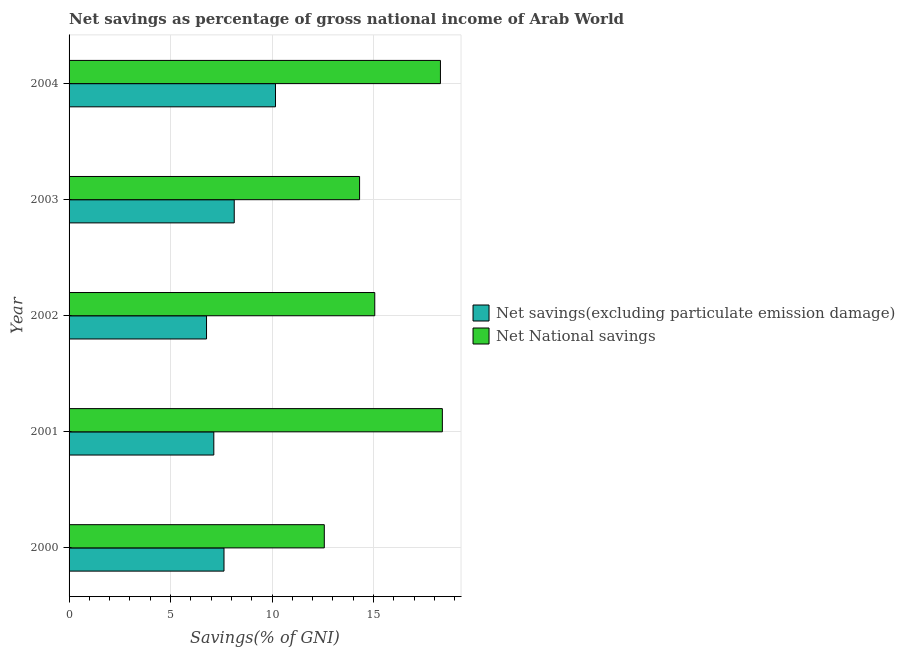How many groups of bars are there?
Give a very brief answer. 5. Are the number of bars per tick equal to the number of legend labels?
Make the answer very short. Yes. In how many cases, is the number of bars for a given year not equal to the number of legend labels?
Offer a very short reply. 0. What is the net savings(excluding particulate emission damage) in 2002?
Offer a terse response. 6.77. Across all years, what is the maximum net savings(excluding particulate emission damage)?
Make the answer very short. 10.17. Across all years, what is the minimum net savings(excluding particulate emission damage)?
Your answer should be compact. 6.77. In which year was the net national savings maximum?
Provide a succinct answer. 2001. In which year was the net savings(excluding particulate emission damage) minimum?
Your answer should be very brief. 2002. What is the total net savings(excluding particulate emission damage) in the graph?
Provide a short and direct response. 39.85. What is the difference between the net national savings in 2000 and that in 2003?
Your response must be concise. -1.74. What is the difference between the net national savings in 2000 and the net savings(excluding particulate emission damage) in 2004?
Keep it short and to the point. 2.41. What is the average net national savings per year?
Provide a succinct answer. 15.73. In the year 2002, what is the difference between the net national savings and net savings(excluding particulate emission damage)?
Your response must be concise. 8.29. In how many years, is the net national savings greater than 8 %?
Ensure brevity in your answer.  5. What is the ratio of the net national savings in 2000 to that in 2002?
Keep it short and to the point. 0.83. Is the net national savings in 2001 less than that in 2002?
Give a very brief answer. No. Is the difference between the net national savings in 2000 and 2003 greater than the difference between the net savings(excluding particulate emission damage) in 2000 and 2003?
Your answer should be very brief. No. What is the difference between the highest and the second highest net savings(excluding particulate emission damage)?
Keep it short and to the point. 2.03. What is the difference between the highest and the lowest net national savings?
Provide a short and direct response. 5.82. In how many years, is the net savings(excluding particulate emission damage) greater than the average net savings(excluding particulate emission damage) taken over all years?
Offer a very short reply. 2. What does the 1st bar from the top in 2002 represents?
Your answer should be compact. Net National savings. What does the 2nd bar from the bottom in 2003 represents?
Keep it short and to the point. Net National savings. Are all the bars in the graph horizontal?
Ensure brevity in your answer.  Yes. Where does the legend appear in the graph?
Give a very brief answer. Center right. How are the legend labels stacked?
Keep it short and to the point. Vertical. What is the title of the graph?
Offer a very short reply. Net savings as percentage of gross national income of Arab World. What is the label or title of the X-axis?
Provide a short and direct response. Savings(% of GNI). What is the Savings(% of GNI) of Net savings(excluding particulate emission damage) in 2000?
Provide a succinct answer. 7.63. What is the Savings(% of GNI) of Net National savings in 2000?
Keep it short and to the point. 12.58. What is the Savings(% of GNI) in Net savings(excluding particulate emission damage) in 2001?
Provide a short and direct response. 7.13. What is the Savings(% of GNI) in Net National savings in 2001?
Offer a very short reply. 18.39. What is the Savings(% of GNI) in Net savings(excluding particulate emission damage) in 2002?
Offer a terse response. 6.77. What is the Savings(% of GNI) in Net National savings in 2002?
Ensure brevity in your answer.  15.06. What is the Savings(% of GNI) of Net savings(excluding particulate emission damage) in 2003?
Give a very brief answer. 8.14. What is the Savings(% of GNI) in Net National savings in 2003?
Provide a short and direct response. 14.32. What is the Savings(% of GNI) in Net savings(excluding particulate emission damage) in 2004?
Offer a very short reply. 10.17. What is the Savings(% of GNI) in Net National savings in 2004?
Your answer should be compact. 18.3. Across all years, what is the maximum Savings(% of GNI) of Net savings(excluding particulate emission damage)?
Make the answer very short. 10.17. Across all years, what is the maximum Savings(% of GNI) of Net National savings?
Provide a short and direct response. 18.39. Across all years, what is the minimum Savings(% of GNI) of Net savings(excluding particulate emission damage)?
Offer a terse response. 6.77. Across all years, what is the minimum Savings(% of GNI) of Net National savings?
Ensure brevity in your answer.  12.58. What is the total Savings(% of GNI) of Net savings(excluding particulate emission damage) in the graph?
Give a very brief answer. 39.85. What is the total Savings(% of GNI) of Net National savings in the graph?
Give a very brief answer. 78.65. What is the difference between the Savings(% of GNI) of Net savings(excluding particulate emission damage) in 2000 and that in 2001?
Offer a very short reply. 0.5. What is the difference between the Savings(% of GNI) in Net National savings in 2000 and that in 2001?
Your response must be concise. -5.82. What is the difference between the Savings(% of GNI) of Net savings(excluding particulate emission damage) in 2000 and that in 2002?
Ensure brevity in your answer.  0.86. What is the difference between the Savings(% of GNI) of Net National savings in 2000 and that in 2002?
Your answer should be very brief. -2.49. What is the difference between the Savings(% of GNI) in Net savings(excluding particulate emission damage) in 2000 and that in 2003?
Offer a terse response. -0.5. What is the difference between the Savings(% of GNI) in Net National savings in 2000 and that in 2003?
Give a very brief answer. -1.74. What is the difference between the Savings(% of GNI) of Net savings(excluding particulate emission damage) in 2000 and that in 2004?
Your answer should be very brief. -2.54. What is the difference between the Savings(% of GNI) of Net National savings in 2000 and that in 2004?
Offer a terse response. -5.72. What is the difference between the Savings(% of GNI) of Net savings(excluding particulate emission damage) in 2001 and that in 2002?
Your answer should be compact. 0.36. What is the difference between the Savings(% of GNI) of Net National savings in 2001 and that in 2002?
Keep it short and to the point. 3.33. What is the difference between the Savings(% of GNI) of Net savings(excluding particulate emission damage) in 2001 and that in 2003?
Ensure brevity in your answer.  -1.01. What is the difference between the Savings(% of GNI) of Net National savings in 2001 and that in 2003?
Keep it short and to the point. 4.08. What is the difference between the Savings(% of GNI) in Net savings(excluding particulate emission damage) in 2001 and that in 2004?
Provide a succinct answer. -3.04. What is the difference between the Savings(% of GNI) of Net National savings in 2001 and that in 2004?
Provide a succinct answer. 0.09. What is the difference between the Savings(% of GNI) in Net savings(excluding particulate emission damage) in 2002 and that in 2003?
Your response must be concise. -1.37. What is the difference between the Savings(% of GNI) in Net National savings in 2002 and that in 2003?
Provide a succinct answer. 0.75. What is the difference between the Savings(% of GNI) in Net savings(excluding particulate emission damage) in 2002 and that in 2004?
Keep it short and to the point. -3.4. What is the difference between the Savings(% of GNI) of Net National savings in 2002 and that in 2004?
Your answer should be compact. -3.24. What is the difference between the Savings(% of GNI) of Net savings(excluding particulate emission damage) in 2003 and that in 2004?
Offer a terse response. -2.03. What is the difference between the Savings(% of GNI) in Net National savings in 2003 and that in 2004?
Your answer should be very brief. -3.98. What is the difference between the Savings(% of GNI) in Net savings(excluding particulate emission damage) in 2000 and the Savings(% of GNI) in Net National savings in 2001?
Your answer should be compact. -10.76. What is the difference between the Savings(% of GNI) of Net savings(excluding particulate emission damage) in 2000 and the Savings(% of GNI) of Net National savings in 2002?
Keep it short and to the point. -7.43. What is the difference between the Savings(% of GNI) of Net savings(excluding particulate emission damage) in 2000 and the Savings(% of GNI) of Net National savings in 2003?
Your response must be concise. -6.68. What is the difference between the Savings(% of GNI) in Net savings(excluding particulate emission damage) in 2000 and the Savings(% of GNI) in Net National savings in 2004?
Your response must be concise. -10.67. What is the difference between the Savings(% of GNI) in Net savings(excluding particulate emission damage) in 2001 and the Savings(% of GNI) in Net National savings in 2002?
Offer a terse response. -7.93. What is the difference between the Savings(% of GNI) of Net savings(excluding particulate emission damage) in 2001 and the Savings(% of GNI) of Net National savings in 2003?
Your answer should be very brief. -7.18. What is the difference between the Savings(% of GNI) of Net savings(excluding particulate emission damage) in 2001 and the Savings(% of GNI) of Net National savings in 2004?
Ensure brevity in your answer.  -11.17. What is the difference between the Savings(% of GNI) in Net savings(excluding particulate emission damage) in 2002 and the Savings(% of GNI) in Net National savings in 2003?
Make the answer very short. -7.54. What is the difference between the Savings(% of GNI) in Net savings(excluding particulate emission damage) in 2002 and the Savings(% of GNI) in Net National savings in 2004?
Your answer should be compact. -11.53. What is the difference between the Savings(% of GNI) in Net savings(excluding particulate emission damage) in 2003 and the Savings(% of GNI) in Net National savings in 2004?
Provide a succinct answer. -10.16. What is the average Savings(% of GNI) in Net savings(excluding particulate emission damage) per year?
Your answer should be compact. 7.97. What is the average Savings(% of GNI) in Net National savings per year?
Your answer should be very brief. 15.73. In the year 2000, what is the difference between the Savings(% of GNI) of Net savings(excluding particulate emission damage) and Savings(% of GNI) of Net National savings?
Make the answer very short. -4.94. In the year 2001, what is the difference between the Savings(% of GNI) in Net savings(excluding particulate emission damage) and Savings(% of GNI) in Net National savings?
Your answer should be very brief. -11.26. In the year 2002, what is the difference between the Savings(% of GNI) of Net savings(excluding particulate emission damage) and Savings(% of GNI) of Net National savings?
Your answer should be compact. -8.29. In the year 2003, what is the difference between the Savings(% of GNI) of Net savings(excluding particulate emission damage) and Savings(% of GNI) of Net National savings?
Your response must be concise. -6.18. In the year 2004, what is the difference between the Savings(% of GNI) of Net savings(excluding particulate emission damage) and Savings(% of GNI) of Net National savings?
Keep it short and to the point. -8.13. What is the ratio of the Savings(% of GNI) of Net savings(excluding particulate emission damage) in 2000 to that in 2001?
Offer a terse response. 1.07. What is the ratio of the Savings(% of GNI) in Net National savings in 2000 to that in 2001?
Your answer should be compact. 0.68. What is the ratio of the Savings(% of GNI) of Net savings(excluding particulate emission damage) in 2000 to that in 2002?
Give a very brief answer. 1.13. What is the ratio of the Savings(% of GNI) of Net National savings in 2000 to that in 2002?
Make the answer very short. 0.83. What is the ratio of the Savings(% of GNI) in Net savings(excluding particulate emission damage) in 2000 to that in 2003?
Your answer should be very brief. 0.94. What is the ratio of the Savings(% of GNI) of Net National savings in 2000 to that in 2003?
Your answer should be very brief. 0.88. What is the ratio of the Savings(% of GNI) in Net savings(excluding particulate emission damage) in 2000 to that in 2004?
Provide a short and direct response. 0.75. What is the ratio of the Savings(% of GNI) of Net National savings in 2000 to that in 2004?
Your response must be concise. 0.69. What is the ratio of the Savings(% of GNI) of Net savings(excluding particulate emission damage) in 2001 to that in 2002?
Offer a terse response. 1.05. What is the ratio of the Savings(% of GNI) in Net National savings in 2001 to that in 2002?
Offer a very short reply. 1.22. What is the ratio of the Savings(% of GNI) of Net savings(excluding particulate emission damage) in 2001 to that in 2003?
Ensure brevity in your answer.  0.88. What is the ratio of the Savings(% of GNI) of Net National savings in 2001 to that in 2003?
Your answer should be very brief. 1.28. What is the ratio of the Savings(% of GNI) of Net savings(excluding particulate emission damage) in 2001 to that in 2004?
Offer a terse response. 0.7. What is the ratio of the Savings(% of GNI) in Net National savings in 2001 to that in 2004?
Keep it short and to the point. 1.01. What is the ratio of the Savings(% of GNI) of Net savings(excluding particulate emission damage) in 2002 to that in 2003?
Ensure brevity in your answer.  0.83. What is the ratio of the Savings(% of GNI) in Net National savings in 2002 to that in 2003?
Make the answer very short. 1.05. What is the ratio of the Savings(% of GNI) of Net savings(excluding particulate emission damage) in 2002 to that in 2004?
Ensure brevity in your answer.  0.67. What is the ratio of the Savings(% of GNI) in Net National savings in 2002 to that in 2004?
Your answer should be compact. 0.82. What is the ratio of the Savings(% of GNI) of Net savings(excluding particulate emission damage) in 2003 to that in 2004?
Your answer should be very brief. 0.8. What is the ratio of the Savings(% of GNI) of Net National savings in 2003 to that in 2004?
Your answer should be very brief. 0.78. What is the difference between the highest and the second highest Savings(% of GNI) of Net savings(excluding particulate emission damage)?
Provide a short and direct response. 2.03. What is the difference between the highest and the second highest Savings(% of GNI) of Net National savings?
Offer a terse response. 0.09. What is the difference between the highest and the lowest Savings(% of GNI) in Net savings(excluding particulate emission damage)?
Keep it short and to the point. 3.4. What is the difference between the highest and the lowest Savings(% of GNI) in Net National savings?
Make the answer very short. 5.82. 